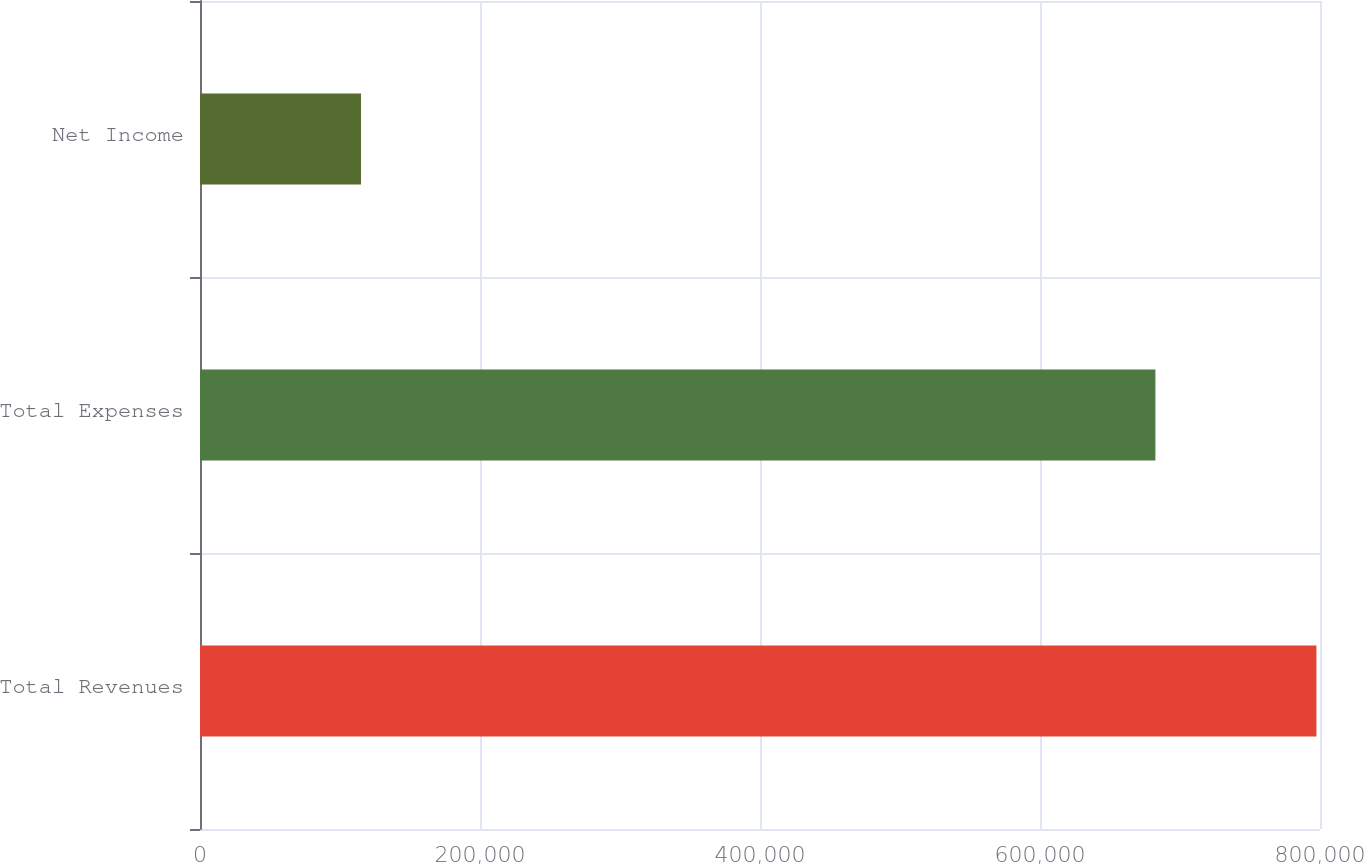Convert chart. <chart><loc_0><loc_0><loc_500><loc_500><bar_chart><fcel>Total Revenues<fcel>Total Expenses<fcel>Net Income<nl><fcel>797441<fcel>682430<fcel>115011<nl></chart> 